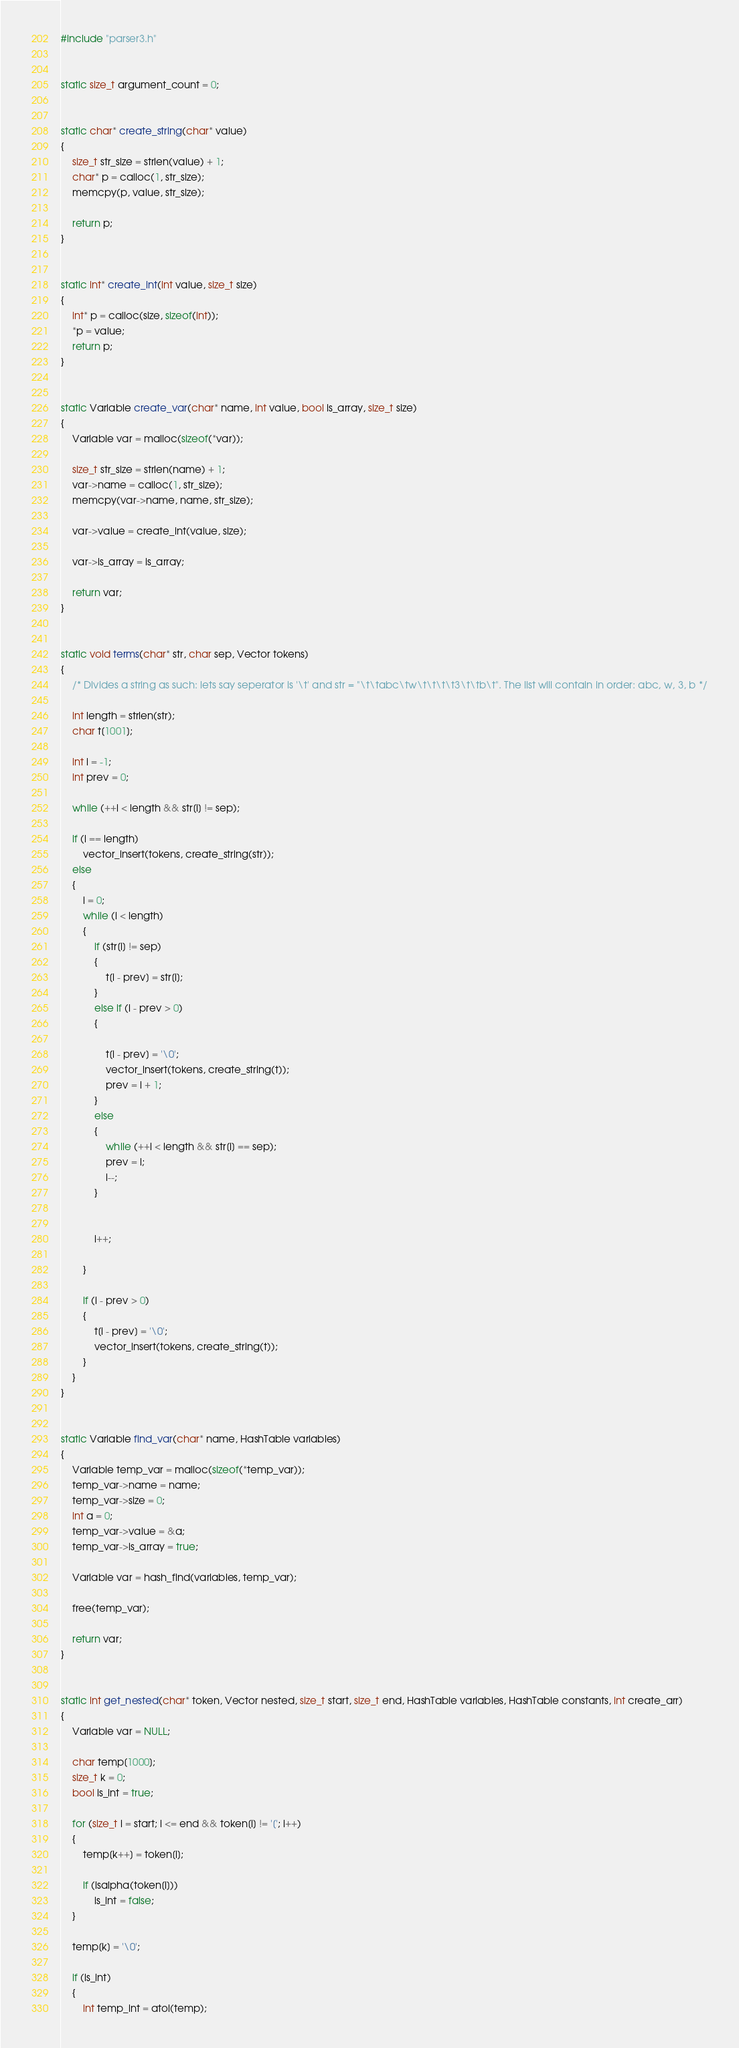Convert code to text. <code><loc_0><loc_0><loc_500><loc_500><_C_>#include "parser3.h"


static size_t argument_count = 0;


static char* create_string(char* value)
{
    size_t str_size = strlen(value) + 1;
    char* p = calloc(1, str_size);
    memcpy(p, value, str_size);

	return p;
}


static int* create_int(int value, size_t size)
{
    int* p = calloc(size, sizeof(int));
    *p = value;
    return p;
}


static Variable create_var(char* name, int value, bool is_array, size_t size)
{
    Variable var = malloc(sizeof(*var));

    size_t str_size = strlen(name) + 1;
    var->name = calloc(1, str_size);
    memcpy(var->name, name, str_size);

    var->value = create_int(value, size);

    var->is_array = is_array;

    return var;
}


static void terms(char* str, char sep, Vector tokens) 
{
    /* Divides a string as such: lets say seperator is '\t' and str = "\t\tabc\tw\t\t\t\t3\t\tb\t". The list will contain in order: abc, w, 3, b */

    int length = strlen(str);
    char t[1001];

    int i = -1;
    int prev = 0;

    while (++i < length && str[i] != sep);

    if (i == length)
        vector_insert(tokens, create_string(str));
    else
    {
        i = 0;
        while (i < length)
        {
            if (str[i] != sep)
            {
                t[i - prev] = str[i];
            }
            else if (i - prev > 0)
            {

                t[i - prev] = '\0';
                vector_insert(tokens, create_string(t));
                prev = i + 1;
            }
            else
            {
                while (++i < length && str[i] == sep);
                prev = i;
                i--;
            }
            

            i++;
                
        }

        if (i - prev > 0)
        {
            t[i - prev] = '\0';
            vector_insert(tokens, create_string(t));
        }
    }
}


static Variable find_var(char* name, HashTable variables)
{
    Variable temp_var = malloc(sizeof(*temp_var));
    temp_var->name = name;
    temp_var->size = 0;
    int a = 0;
    temp_var->value = &a;
    temp_var->is_array = true;

    Variable var = hash_find(variables, temp_var);

    free(temp_var);

    return var;
}


static int get_nested(char* token, Vector nested, size_t start, size_t end, HashTable variables, HashTable constants, int create_arr)
{    
    Variable var = NULL;

    char temp[1000];
    size_t k = 0;
    bool is_int = true;

    for (size_t i = start; i <= end && token[i] != '['; i++)
    {
        temp[k++] = token[i];
        
        if (isalpha(token[i]))
            is_int = false;
    }

    temp[k] = '\0';

    if (is_int)
    {
        int temp_int = atoi(temp);</code> 